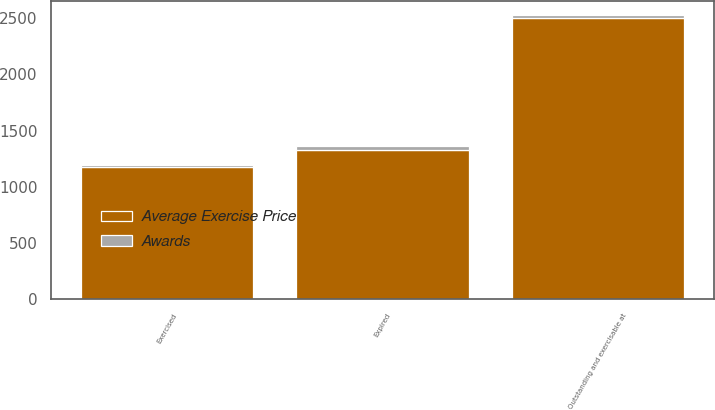Convert chart. <chart><loc_0><loc_0><loc_500><loc_500><stacked_bar_chart><ecel><fcel>Outstanding and exercisable at<fcel>Exercised<fcel>Expired<nl><fcel>Average Exercise Price<fcel>2498<fcel>1173<fcel>1325<nl><fcel>Awards<fcel>30.42<fcel>25.9<fcel>34.42<nl></chart> 